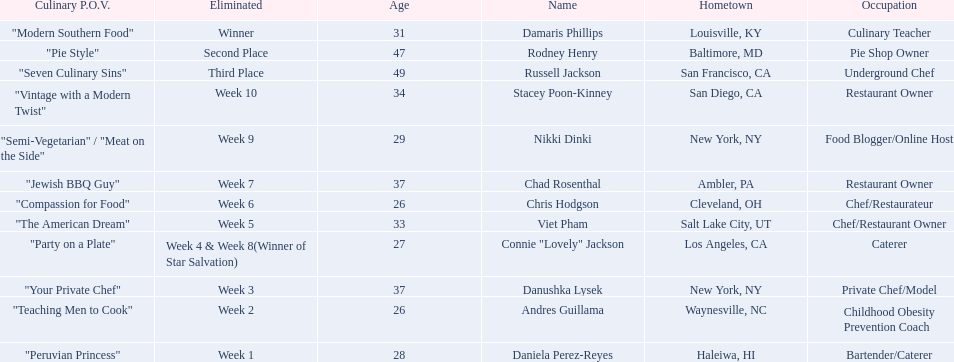Which food network star contestants are in their 20s? Nikki Dinki, Chris Hodgson, Connie "Lovely" Jackson, Andres Guillama, Daniela Perez-Reyes. Of these contestants, which one is the same age as chris hodgson? Andres Guillama. 